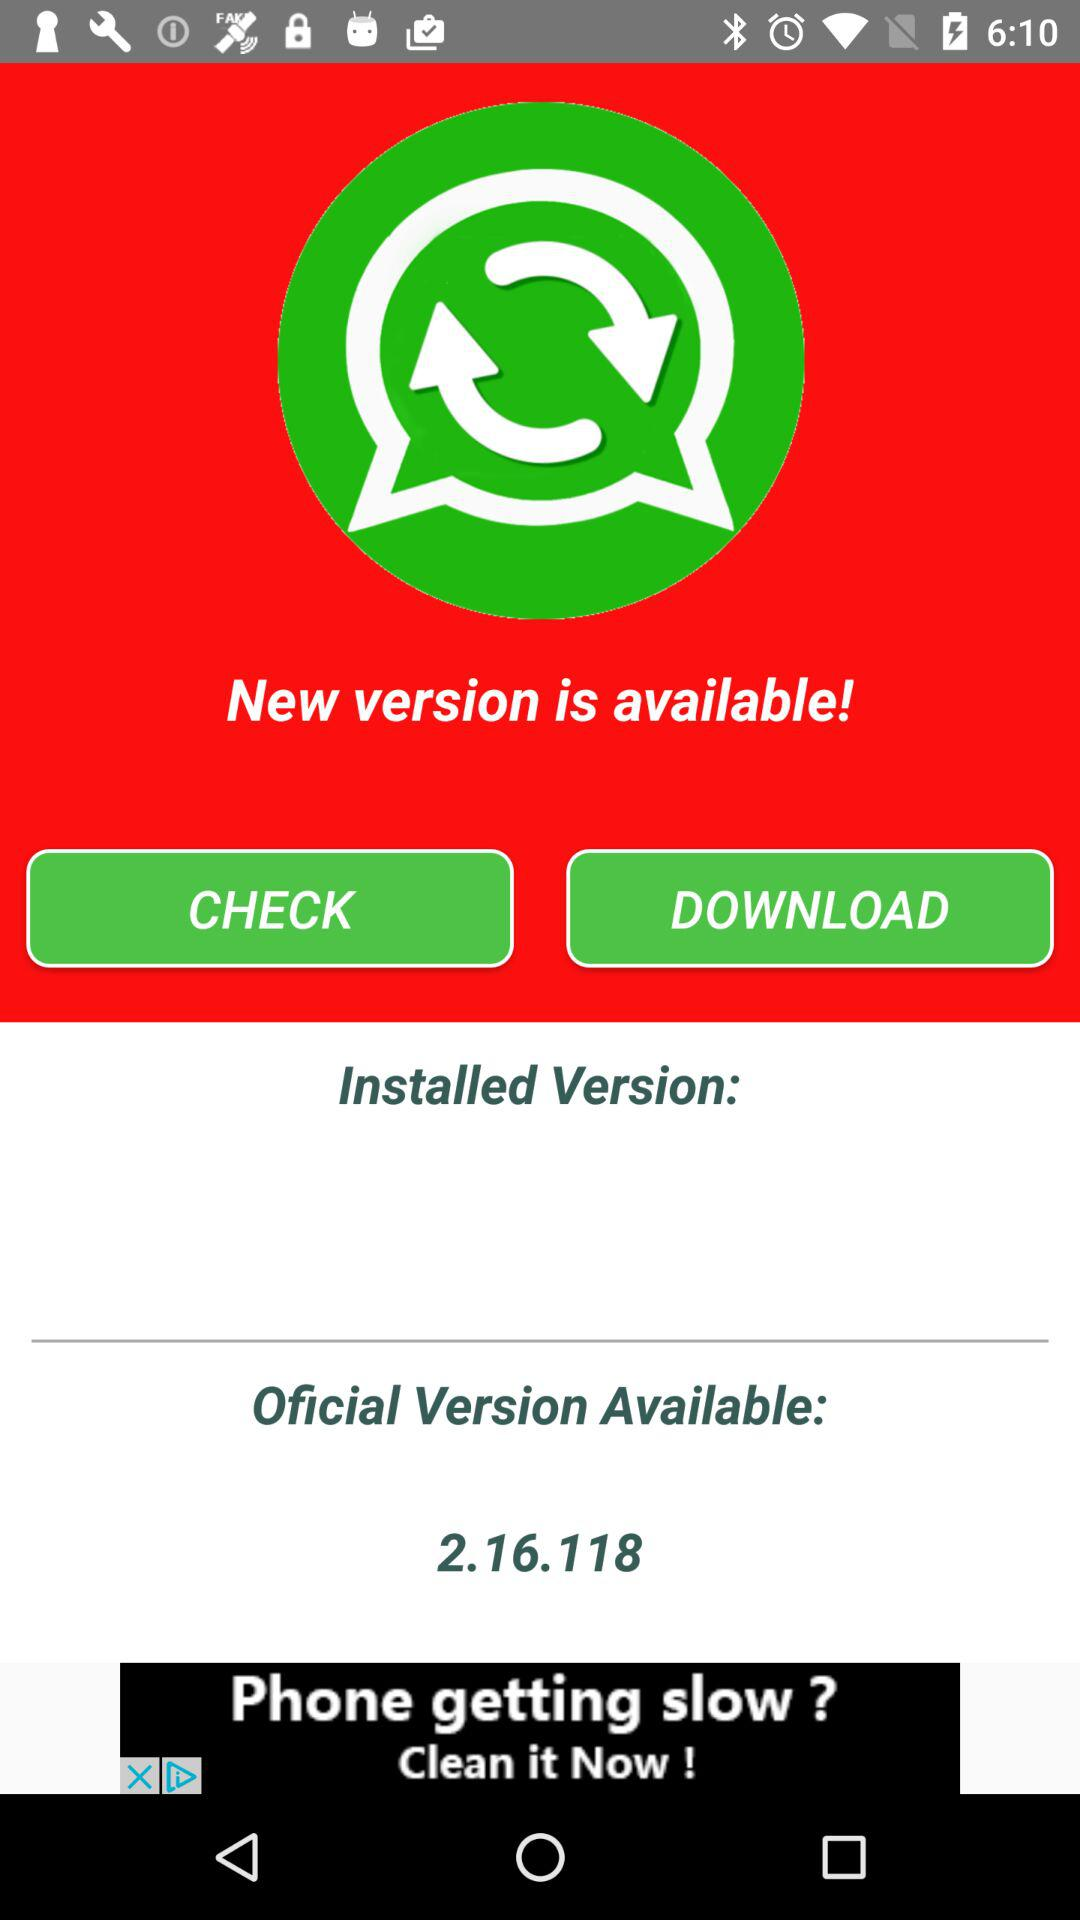What is the official version? The official version is 2.16.118. 